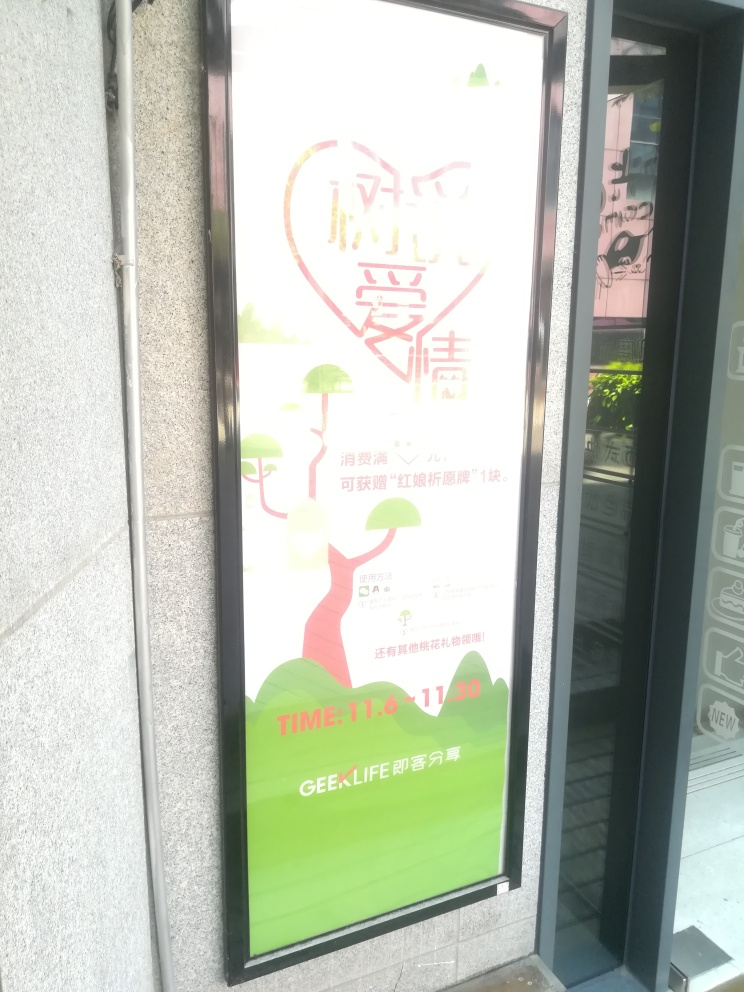What is the overall quality of this image? The overall quality of this image can be considered average, based on the assessment of its visibility and content discernibility. The image is somewhat overexposed, which impacts the visibility of the details and text, making it harder to read. Although the graphic elements such as the heart shape and the green color theme are clear, the important textual information is less so, which could lead to an interpretation of average quality. 